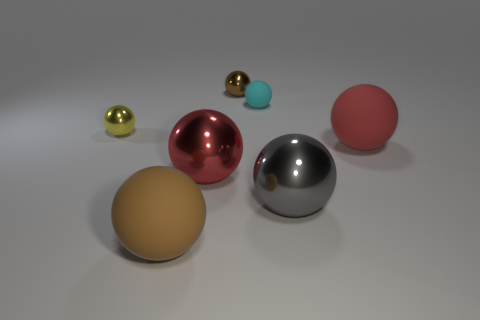Subtract all small brown spheres. How many spheres are left? 6 Add 3 red shiny things. How many objects exist? 10 Subtract all cyan balls. How many balls are left? 6 Subtract all brown cubes. How many red balls are left? 2 Subtract all big brown rubber spheres. Subtract all large things. How many objects are left? 2 Add 1 brown rubber things. How many brown rubber things are left? 2 Add 6 brown metallic things. How many brown metallic things exist? 7 Subtract 0 brown blocks. How many objects are left? 7 Subtract 6 balls. How many balls are left? 1 Subtract all gray spheres. Subtract all brown cylinders. How many spheres are left? 6 